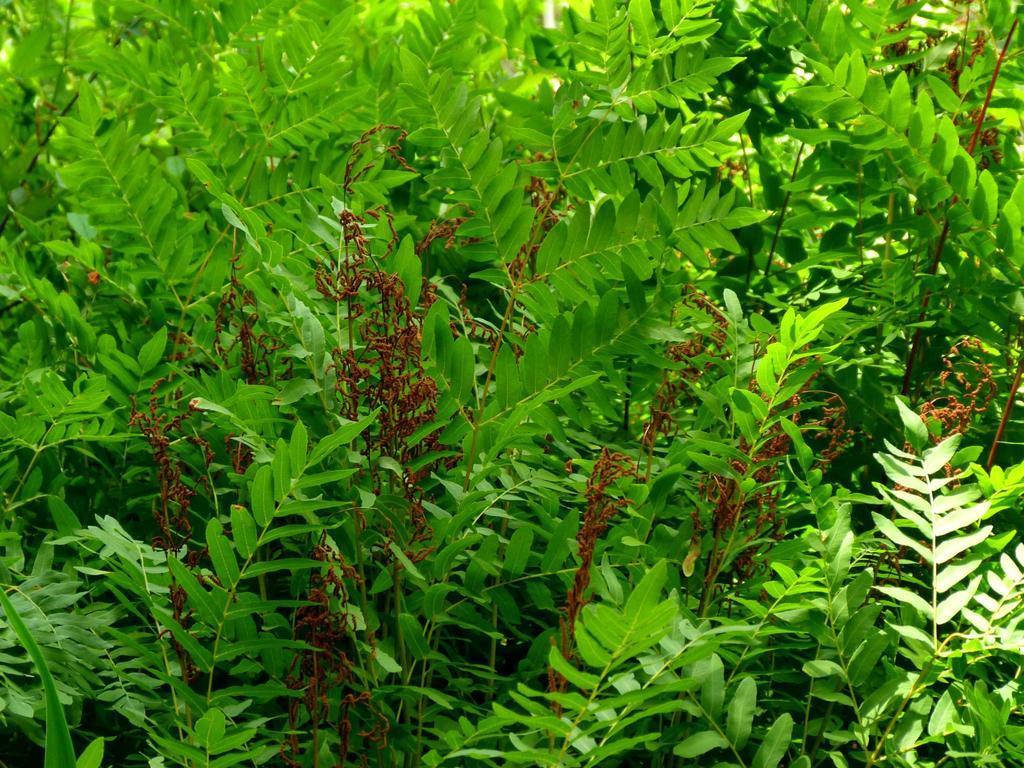Can you describe this image briefly? In this picture there are some green plant with some dry brown leaves. 